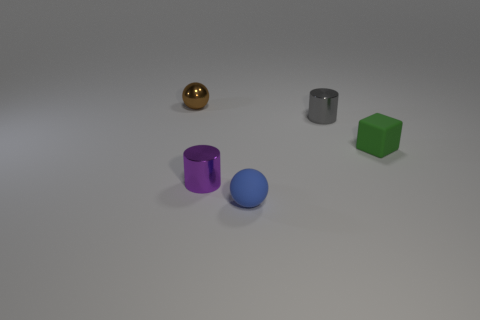Subtract 1 cylinders. How many cylinders are left? 1 Add 4 tiny purple cylinders. How many objects exist? 9 Subtract all purple cylinders. How many cylinders are left? 1 Subtract 1 green blocks. How many objects are left? 4 Subtract all blocks. How many objects are left? 4 Subtract all blue cubes. Subtract all red balls. How many cubes are left? 1 Subtract all gray balls. How many red cylinders are left? 0 Subtract all metallic cylinders. Subtract all small green rubber blocks. How many objects are left? 2 Add 4 blue rubber objects. How many blue rubber objects are left? 5 Add 4 green blocks. How many green blocks exist? 5 